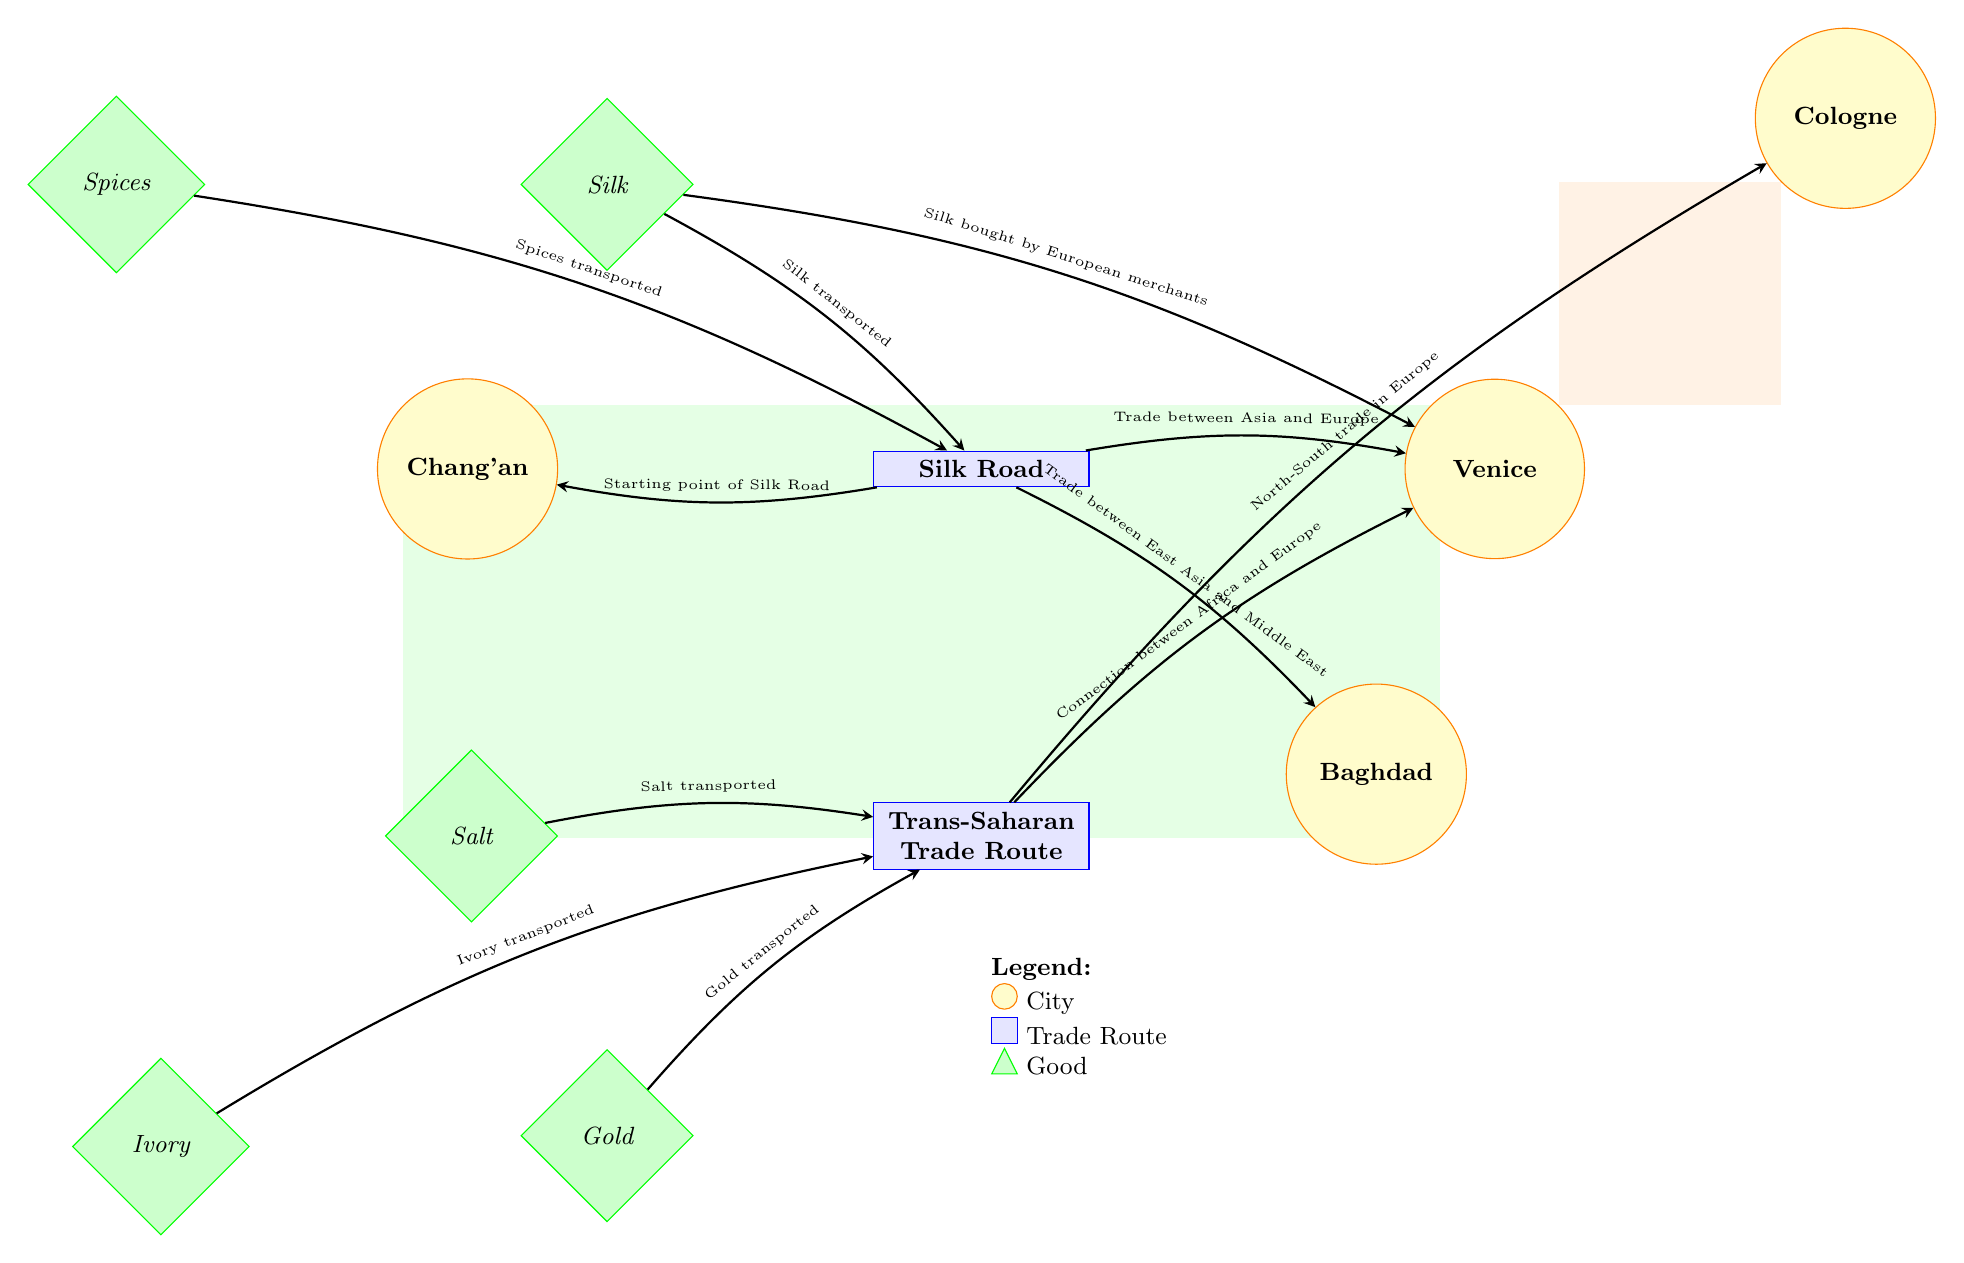What is the starting point of the Silk Road? In the diagram, the Silk Road's starting point is clearly labeled as "Chang'an." It is positioned on the left side of the Silk Road route, indicating that goods originating from this city are traded along the route.
Answer: Chang'an Which goods are commonly transported through the Trans-Saharan Trade Route? The Trans-Saharan Trade Route includes goods such as "Gold," "Salt," and "Ivory." These are represented as labeled diamonds below the route, showing the types of goods exchanged in this trade network.
Answer: Gold, Salt, Ivory How many key trading cities are indicated in the diagram? By counting the circles representing cities in the diagram, we find "Venice," "Baghdad," "Chang'an," and "Cologne." This totals four distinct cities involved in trade.
Answer: 4 What type of goods are transported along the Silk Road? The goods labeled on the Silk Road include "Silk" and "Spices." These items are specifically associated with trade between East and West, as indicated by their positions in relation to the Silk Road.
Answer: Silk, Spices How does ivory get transported according to the diagram? The diagram shows that ivory is transported via the Trans-Saharan Trade Route. It includes a directional connection labeled "Ivory transported" which points to the route, illustrating how ivory is part of the trade conducted along that path.
Answer: Trans-Saharan Trade Route Which city is the endpoint for goods traded on the Silk Road? The diagram indicates that "Venice" serves as one of the endpoints for goods transported along the Silk Road. It is connected with a directional arrow highlighting the movement of goods into the city.
Answer: Venice What is the relationship between Venice and the Silk Road? The diagram illustrates a direct connection between Venice and the Silk Road, with a labeled arrow that indicates "Trade between Asia and Europe." This shows that Venice acts as a crucial center for the exchange of goods coming from the Silk Road.
Answer: Trade between Asia and Europe What items are illustrated as being transported to Venice? The diagram specifies that "Silk" is transported to Venice and that it is a good purchased by European merchants, as indicated by the connection labeled "Silk bought by European merchants."
Answer: Silk 